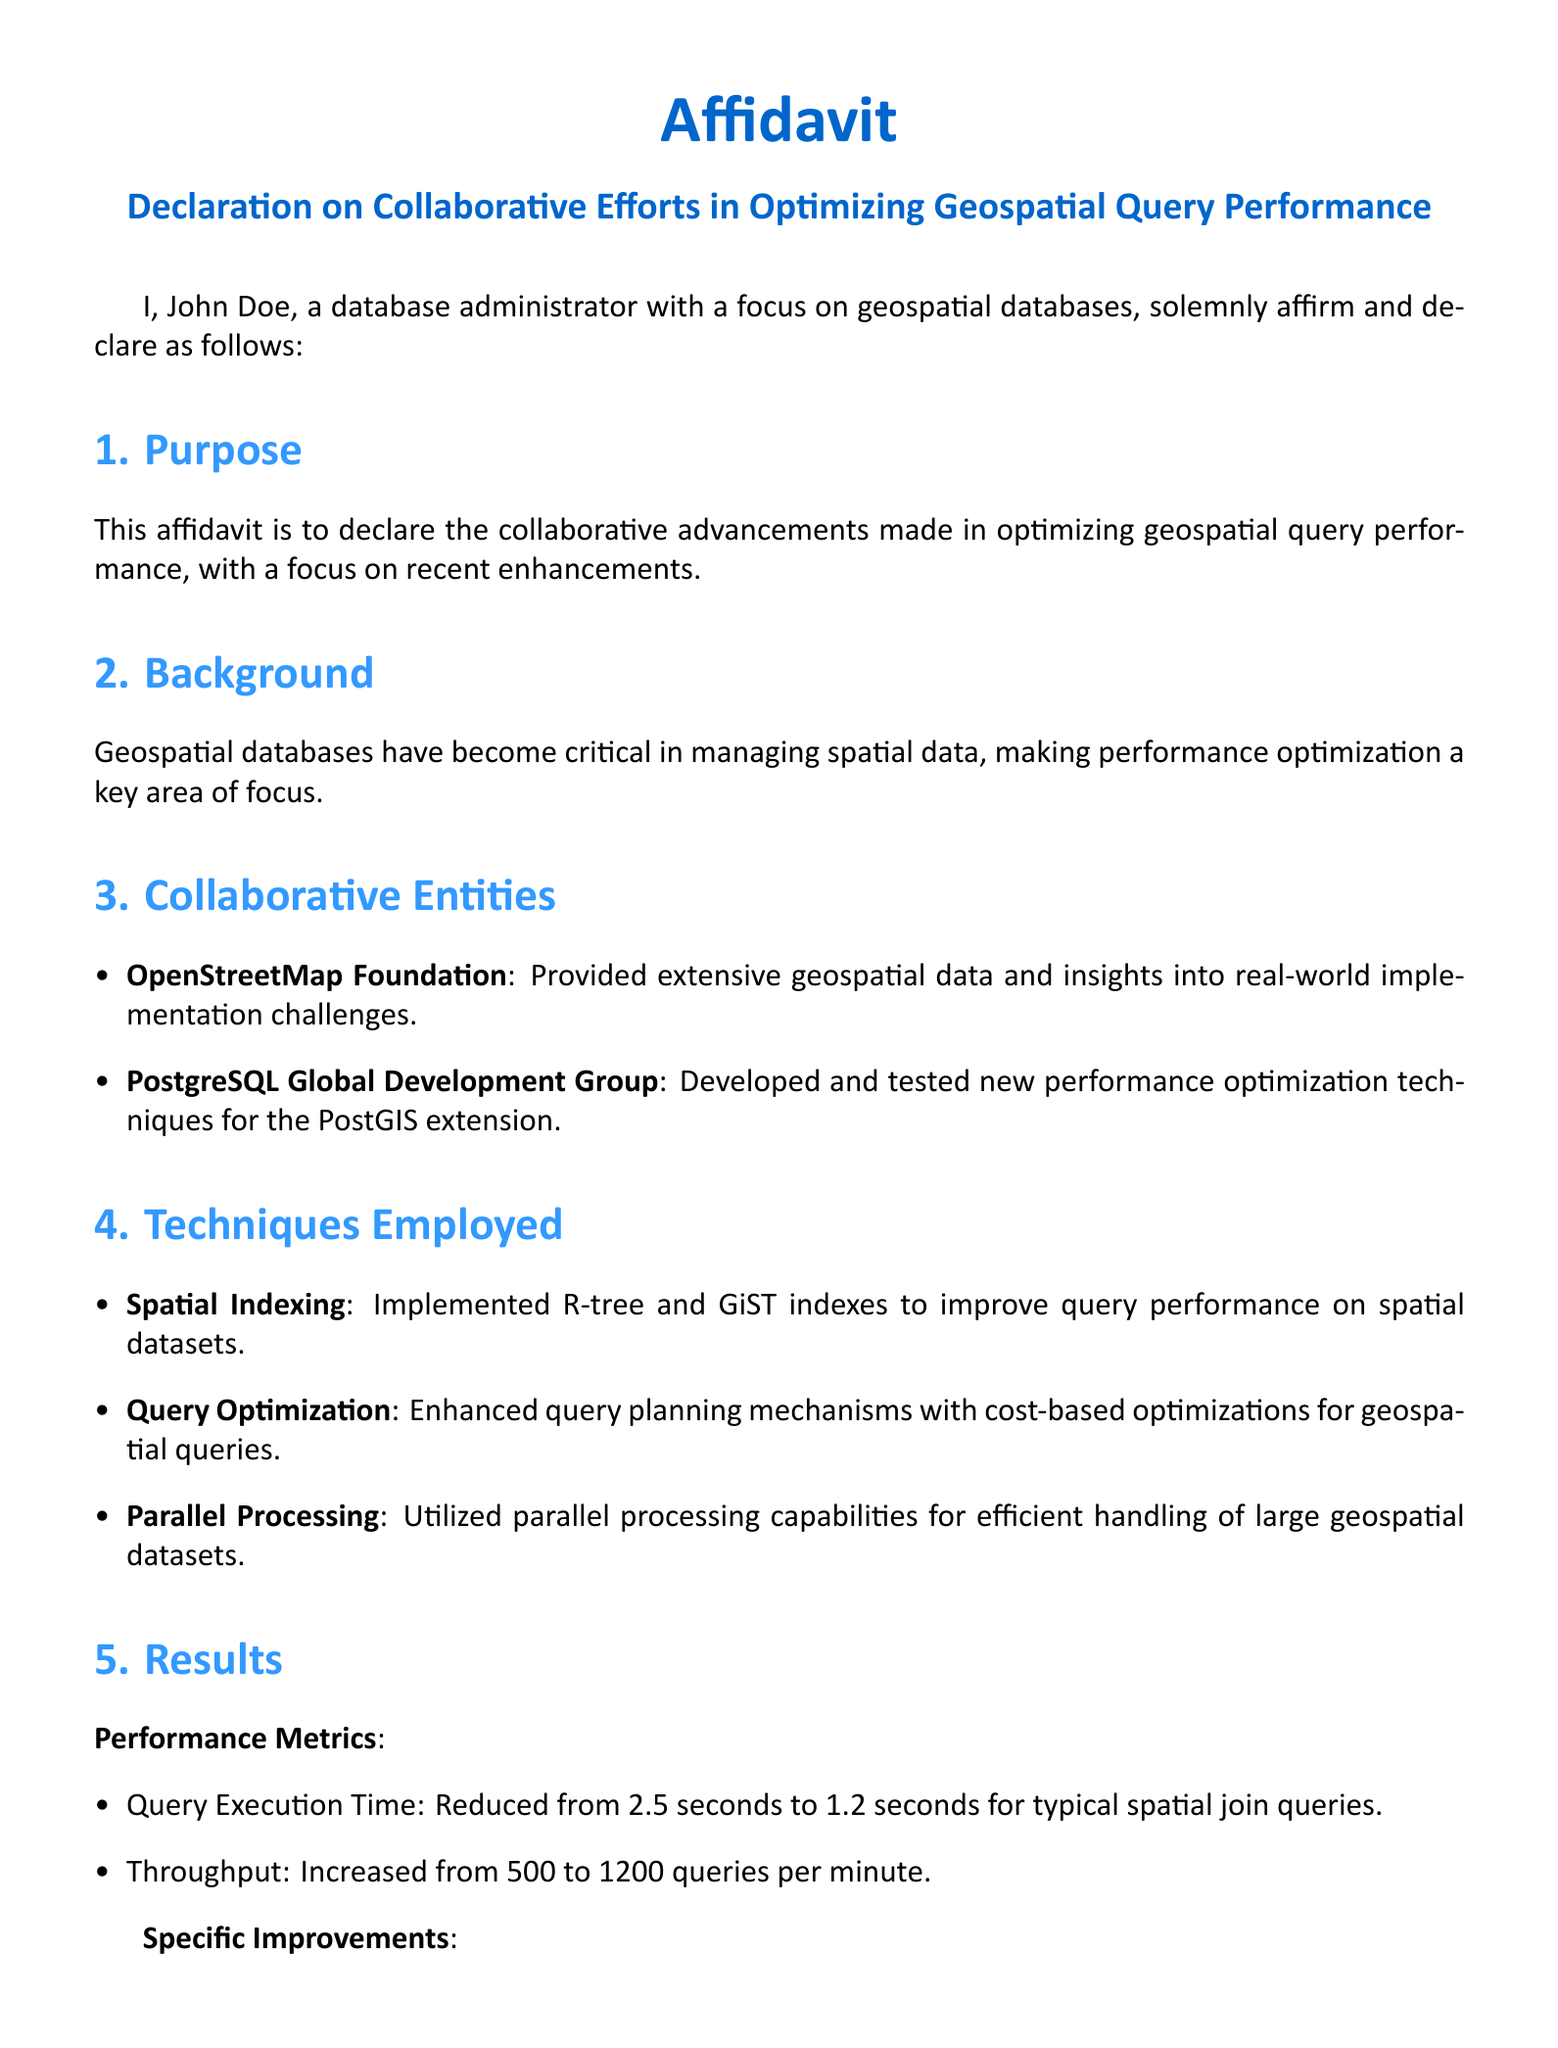What is the name of the affidavit? The affidavit is titled "Declaration on Collaborative Efforts in Optimizing Geospatial Query Performance."
Answer: Declaration on Collaborative Efforts in Optimizing Geospatial Query Performance Who is the affiant? The affiant is the person who is making the declaration, which in this case is John Doe.
Answer: John Doe What is the primary purpose of this affidavit? The primary purpose is to declare the collaborative advancements made in optimizing geospatial query performance.
Answer: To declare the collaborative advancements made in optimizing geospatial query performance Which organization provided extensive geospatial data? The organization that provided extensive geospatial data is OpenStreetMap Foundation.
Answer: OpenStreetMap Foundation What was the query execution time reduced to? The query execution time was reduced from 2.5 seconds to 1.2 seconds.
Answer: 1.2 seconds What technique is used to improve query performance on spatial datasets? The technique used is Spatial Indexing.
Answer: Spatial Indexing What was the increase in query throughput? The throughput increased from 500 queries per minute to 1200 queries per minute.
Answer: 1200 queries per minute What is one of the sectors benefiting from the collaborative efforts? The sectors that benefit include environmental monitoring, urban planning, and transportation.
Answer: Environmental monitoring What is the email address of the affiant? The document provides John Doe's email address.
Answer: john.doe@example.com 